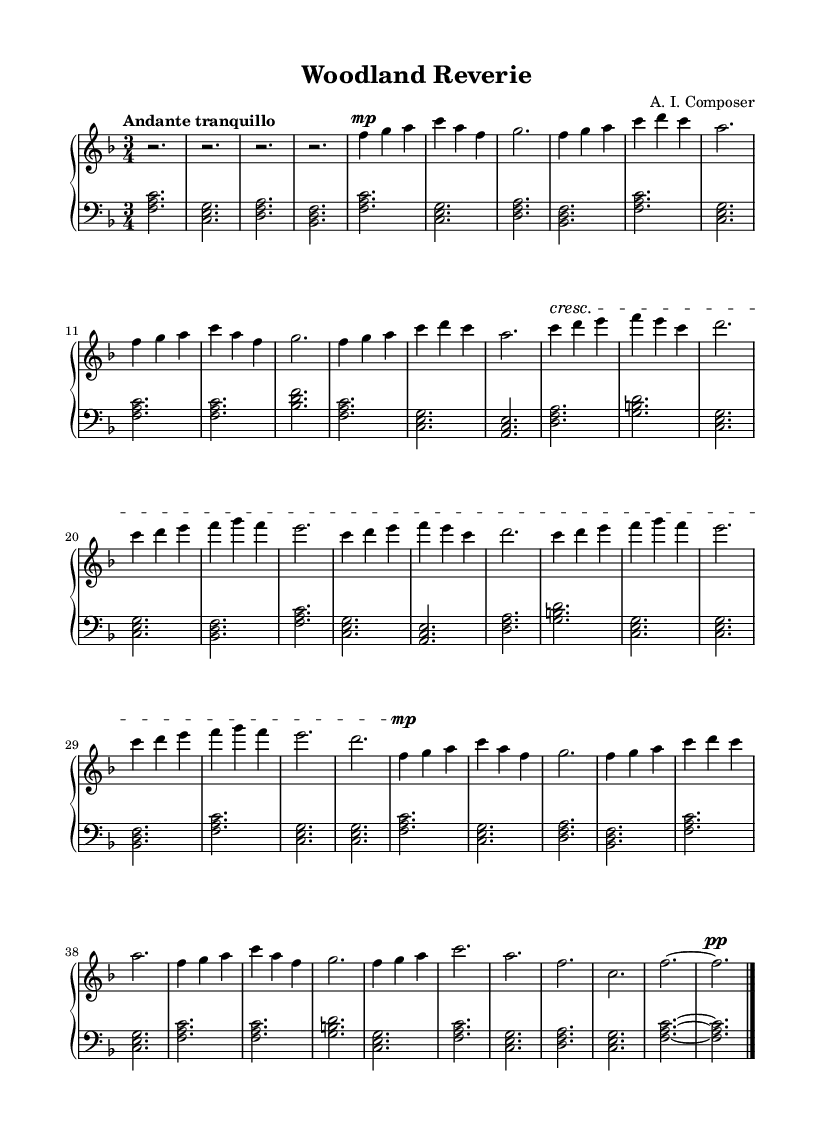what is the key signature of this music? The key signature is indicated at the beginning of the score. The two flat symbols appear on the staff, indicating B flat and E flat, which defines F major.
Answer: F major what is the time signature of this music? The time signature is shown at the beginning of the score, displayed as a fraction on the staff. It indicates three beats per measure.
Answer: 3/4 what is the tempo marking for this piece? The tempo marking is provided in Italian terms, indicating the speed of the music. "Andante tranquillo" is specified.
Answer: Andante tranquillo how many sections does the music have? By analyzing the structure of the music, it is separated into distinct sections labeled A, B, and A' along with a Coda, confirming four main sections.
Answer: 4 what is the dynamic marking for the main theme? Observing the music, the main theme begins with a mezzo-piano marking which indicates a moderate level of loudness.
Answer: mezzo-piano which section features a crescendo? The sheet music displays a crescendo in the B section, specifically starting at a dynamic marking suggesting the increase in volume.
Answer: B section what instruments are included in this score? The music notation shows a piano staff, indicating that the composition is meant to be played on a piano instrument.
Answer: Piano 